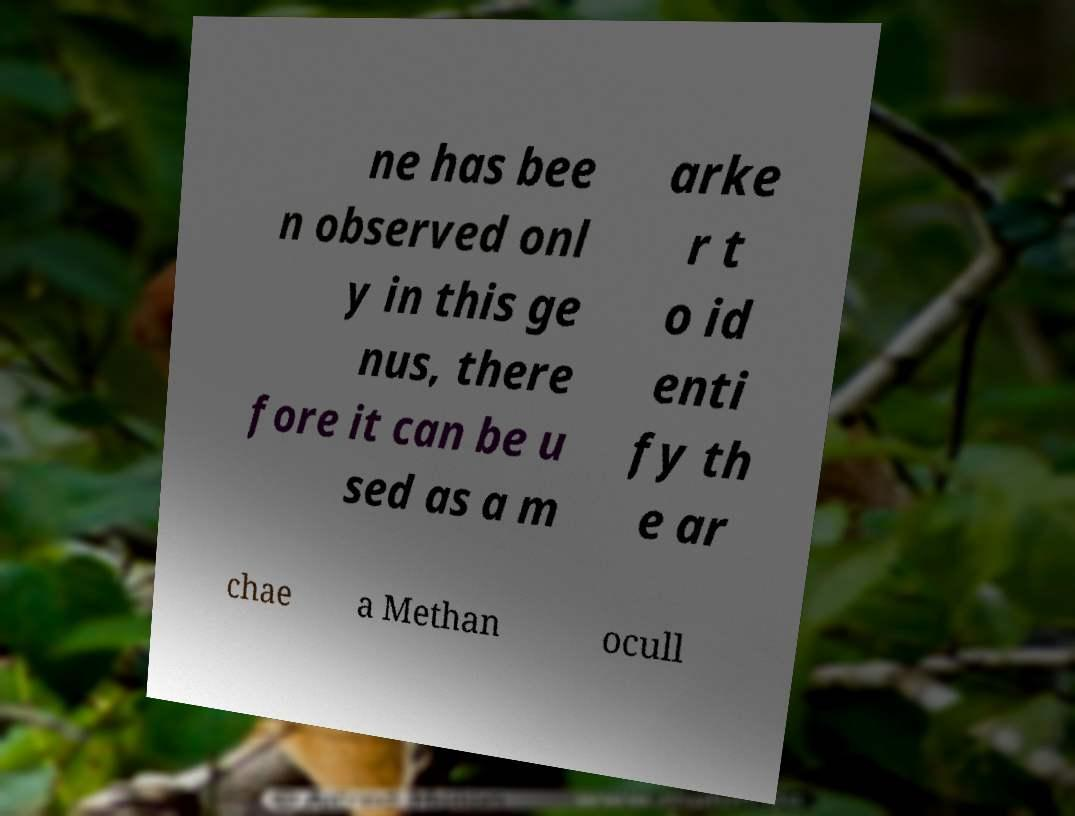Can you accurately transcribe the text from the provided image for me? ne has bee n observed onl y in this ge nus, there fore it can be u sed as a m arke r t o id enti fy th e ar chae a Methan ocull 